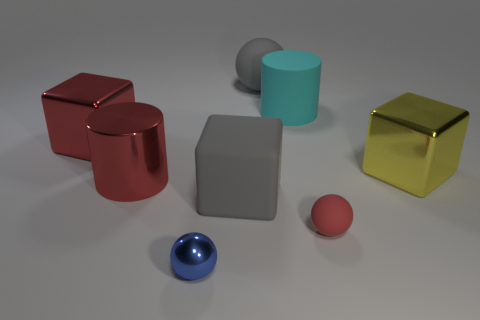What is the color of the cylinder that is behind the big metallic cube on the left side of the small red rubber sphere that is on the right side of the big red metal cylinder? cyan 